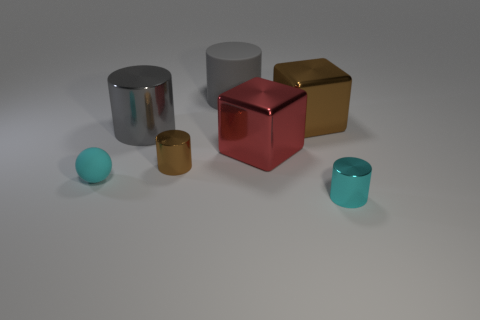Is there a sense of perspective or depth in the image, and what could that suggest about the possible size of these objects? The image has a shallow depth of field with all objects in focus, which suggests the scene is not vast in scale, likely representing a tabletop arrangement. The perspective is such that the objects appear smaller the further they are from the viewpoint, creating a sense of three-dimensional space and potential varying sizes for the objects. 